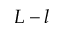Convert formula to latex. <formula><loc_0><loc_0><loc_500><loc_500>L - l</formula> 